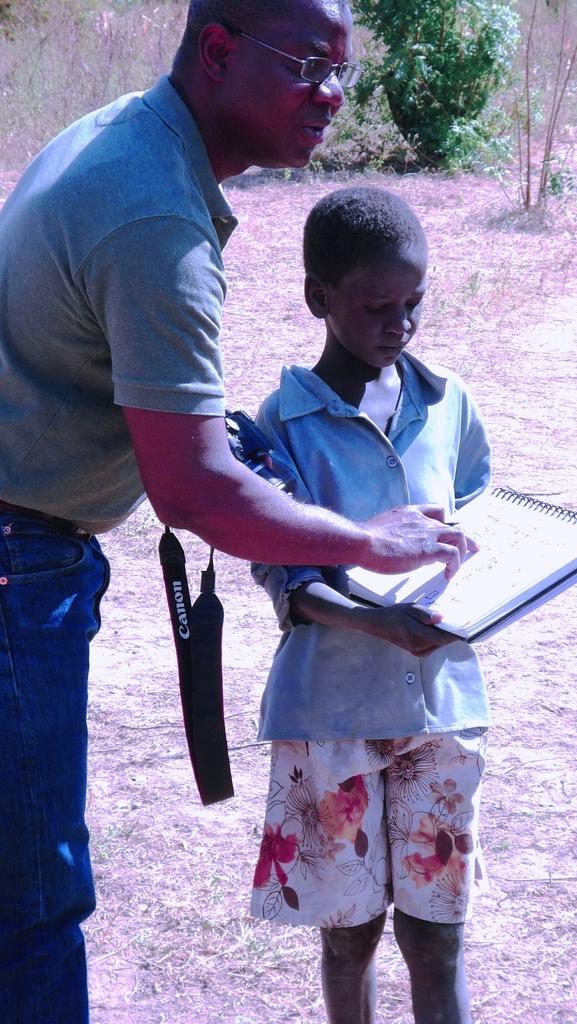Describe this image in one or two sentences. In this image on the left side there is a man standing and holding a camera in his hand. In the center there is a boy standing and holding a book in his hand. In the background there is a tree. 